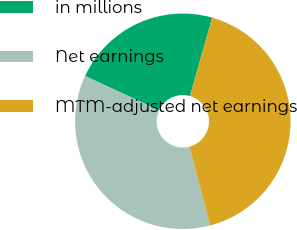Convert chart. <chart><loc_0><loc_0><loc_500><loc_500><pie_chart><fcel>in millions<fcel>Net earnings<fcel>MTM-adjusted net earnings<nl><fcel>22.49%<fcel>35.99%<fcel>41.51%<nl></chart> 